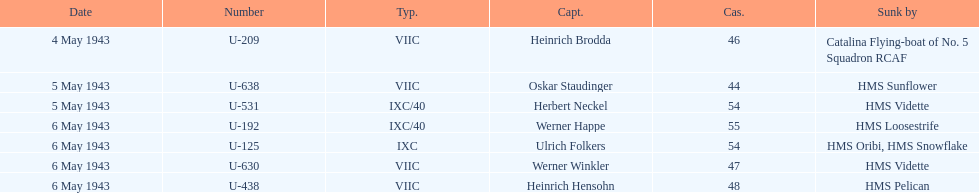What was the only captain sunk by hms pelican? Heinrich Hensohn. 